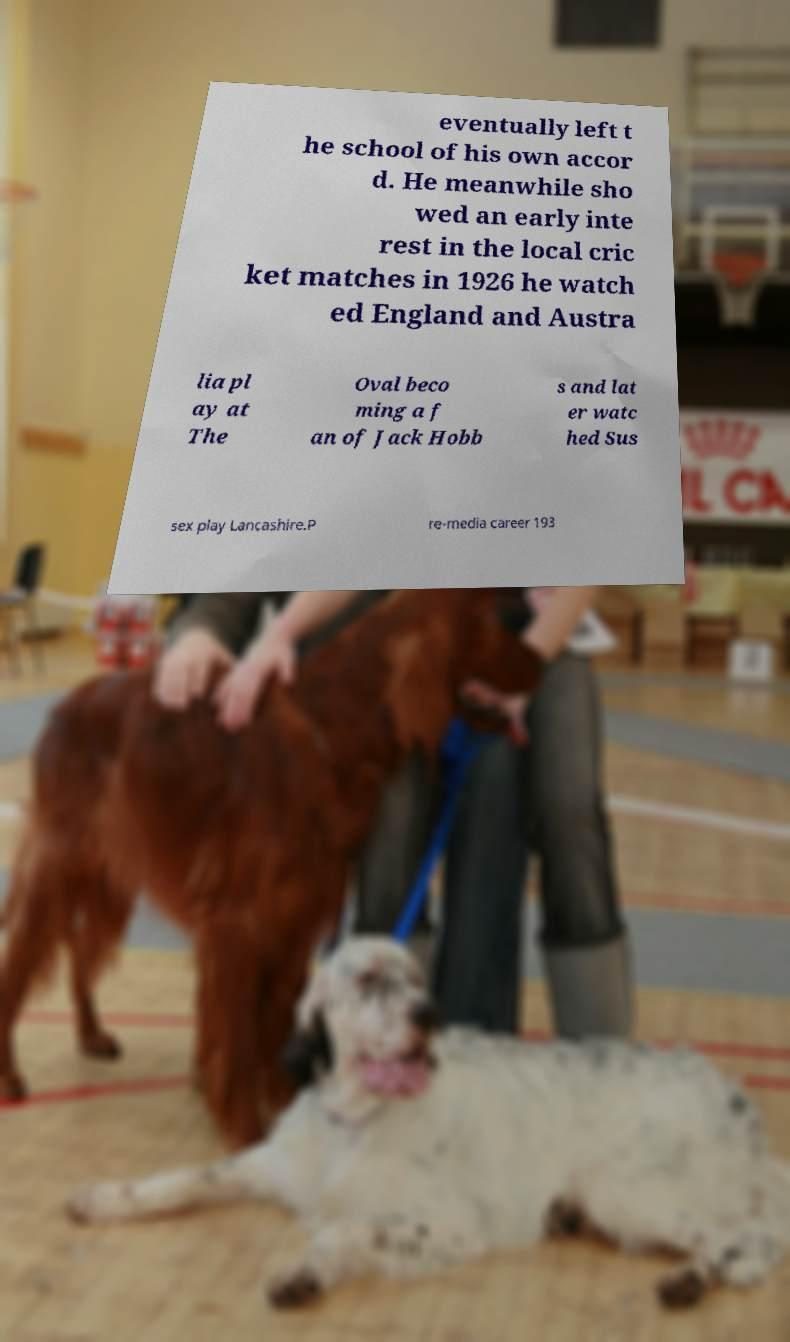Can you read and provide the text displayed in the image?This photo seems to have some interesting text. Can you extract and type it out for me? eventually left t he school of his own accor d. He meanwhile sho wed an early inte rest in the local cric ket matches in 1926 he watch ed England and Austra lia pl ay at The Oval beco ming a f an of Jack Hobb s and lat er watc hed Sus sex play Lancashire.P re-media career 193 